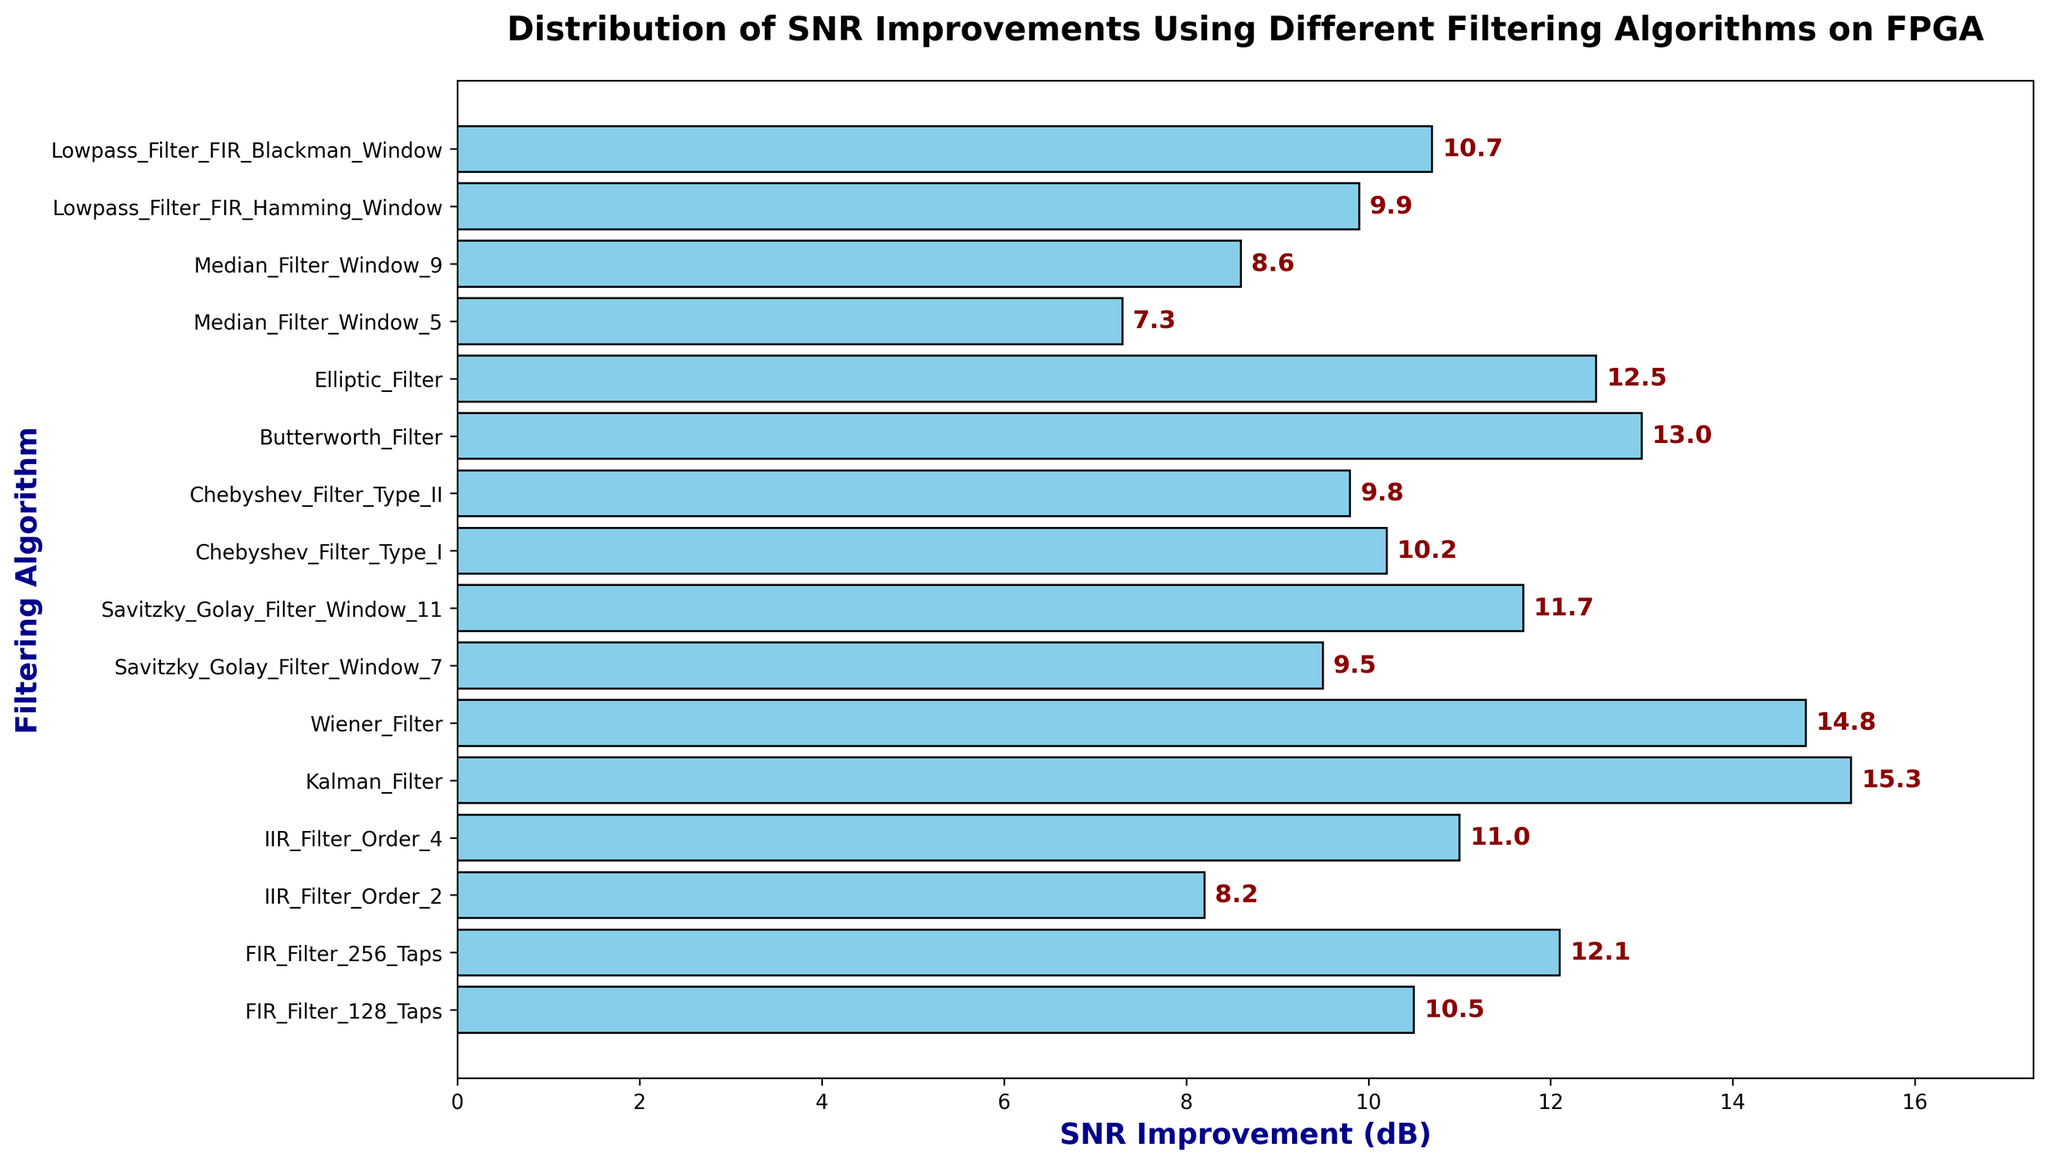What is the SNR improvement for the Kalman Filter? Locate the bar corresponding to the "Kalman Filter" and observe its length, which indicates the SNR improvement.
Answer: 15.3 dB Which filtering algorithm offers the highest SNR improvement? Look for the tallest bar in the chart and identify the corresponding algorithm beside it.
Answer: Kalman Filter How much more SNR improvement does the Wiener Filter provide compared to the Chebyshev Filter Type I? Find the SNR improvements for both filters (Wiener Filter: 14.8 dB, Chebyshev Filter Type I: 10.2 dB) and calculate the difference (14.8 - 10.2).
Answer: 4.6 dB What is the average SNR improvement of all the FIR Filters? Add the SNR improvements for FIR Filter 128 Taps and FIR Filter 256 Taps (10.5 + 12.1) and divide by the number of filters (2).
Answer: 11.3 dB Is the SNR improvement of the Elliptic Filter greater than that of the Butterworth Filter? Compare the lengths of the bars for "Elliptic Filter" (12.5 dB) and "Butterworth Filter" (13.0 dB).
Answer: No What is the combined SNR improvement of both Median Filters? Add the SNR improvements for Median Filter Window 5 and Median Filter Window 9 (7.3 + 8.6).
Answer: 15.9 dB Which Savitzky-Golay Filter configuration offers better SNR improvement? Compare the SNR improvements of Savitzky-Golay Filter Window 7 (9.5 dB) and Savitzky-Golay Filter Window 11 (11.7 dB).
Answer: Savitzky-Golay Filter Window 11 How does the SNR improvement of the FIR Filter with a Blackman Window compare to that with a Hamming Window? Compare the SNR improvements of Lowpass Filter FIR Blackman Window (10.7 dB) and Lowpass Filter FIR Hamming Window (9.9 dB).
Answer: Higher Calculate the total SNR improvement for all IIR Filters. Sum the SNR improvements for IIR Filter Order 2 and IIR Filter Order 4 (8.2 + 11.0).
Answer: 19.2 dB Which algorithm has the lowest SNR improvement, and what is its value? Locate the shortest bar in the chart and identify the corresponding algorithm and its SNR improvement value.
Answer: Median Filter Window 5, 7.3 dB 